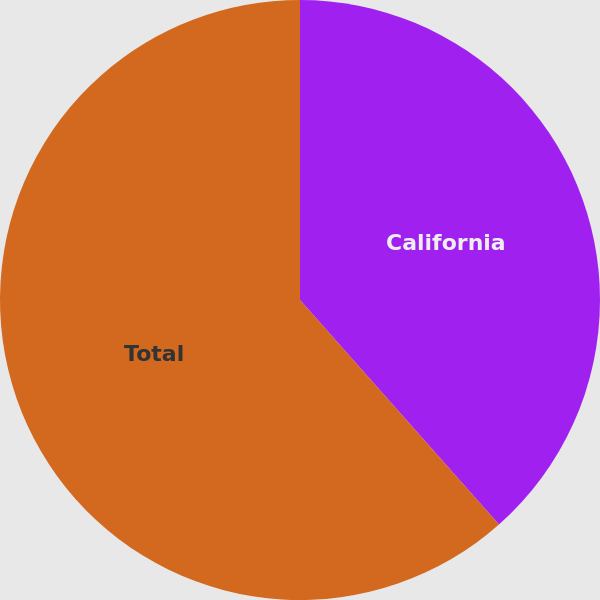Convert chart. <chart><loc_0><loc_0><loc_500><loc_500><pie_chart><fcel>California<fcel>Total<nl><fcel>38.46%<fcel>61.54%<nl></chart> 